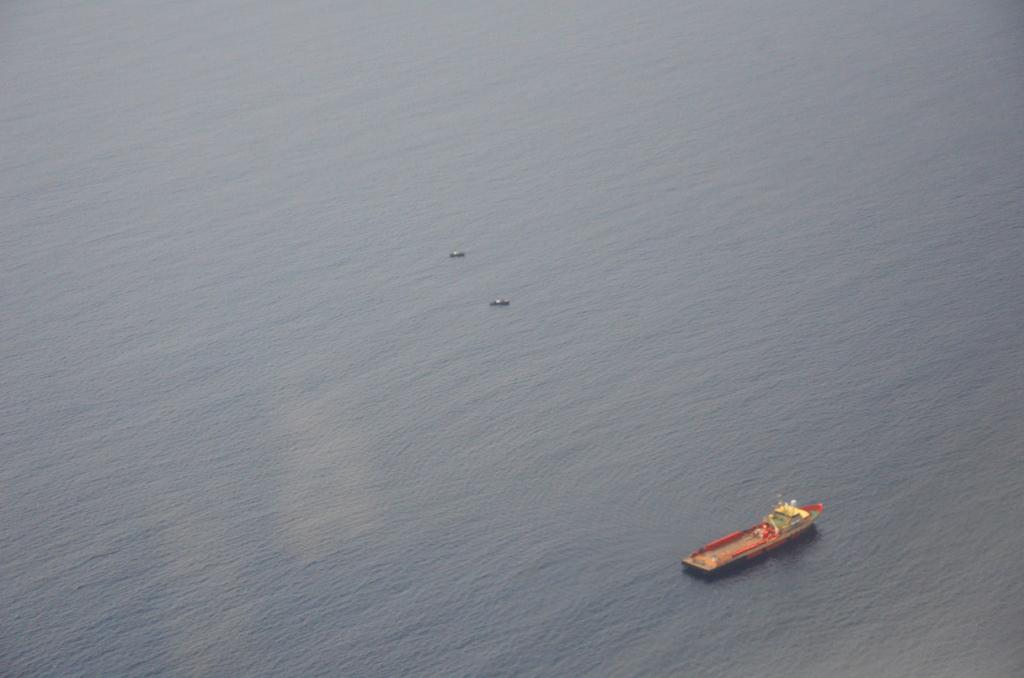What is the main subject of the image? The main subject of the image is a boat. Where is the boat located in the image? The boat is at the bottom side of the image. What type of environment is depicted in the image? There is water around the area of the image. What type of glass can be seen in the boat in the image? There is no glass present in the boat or the image. 